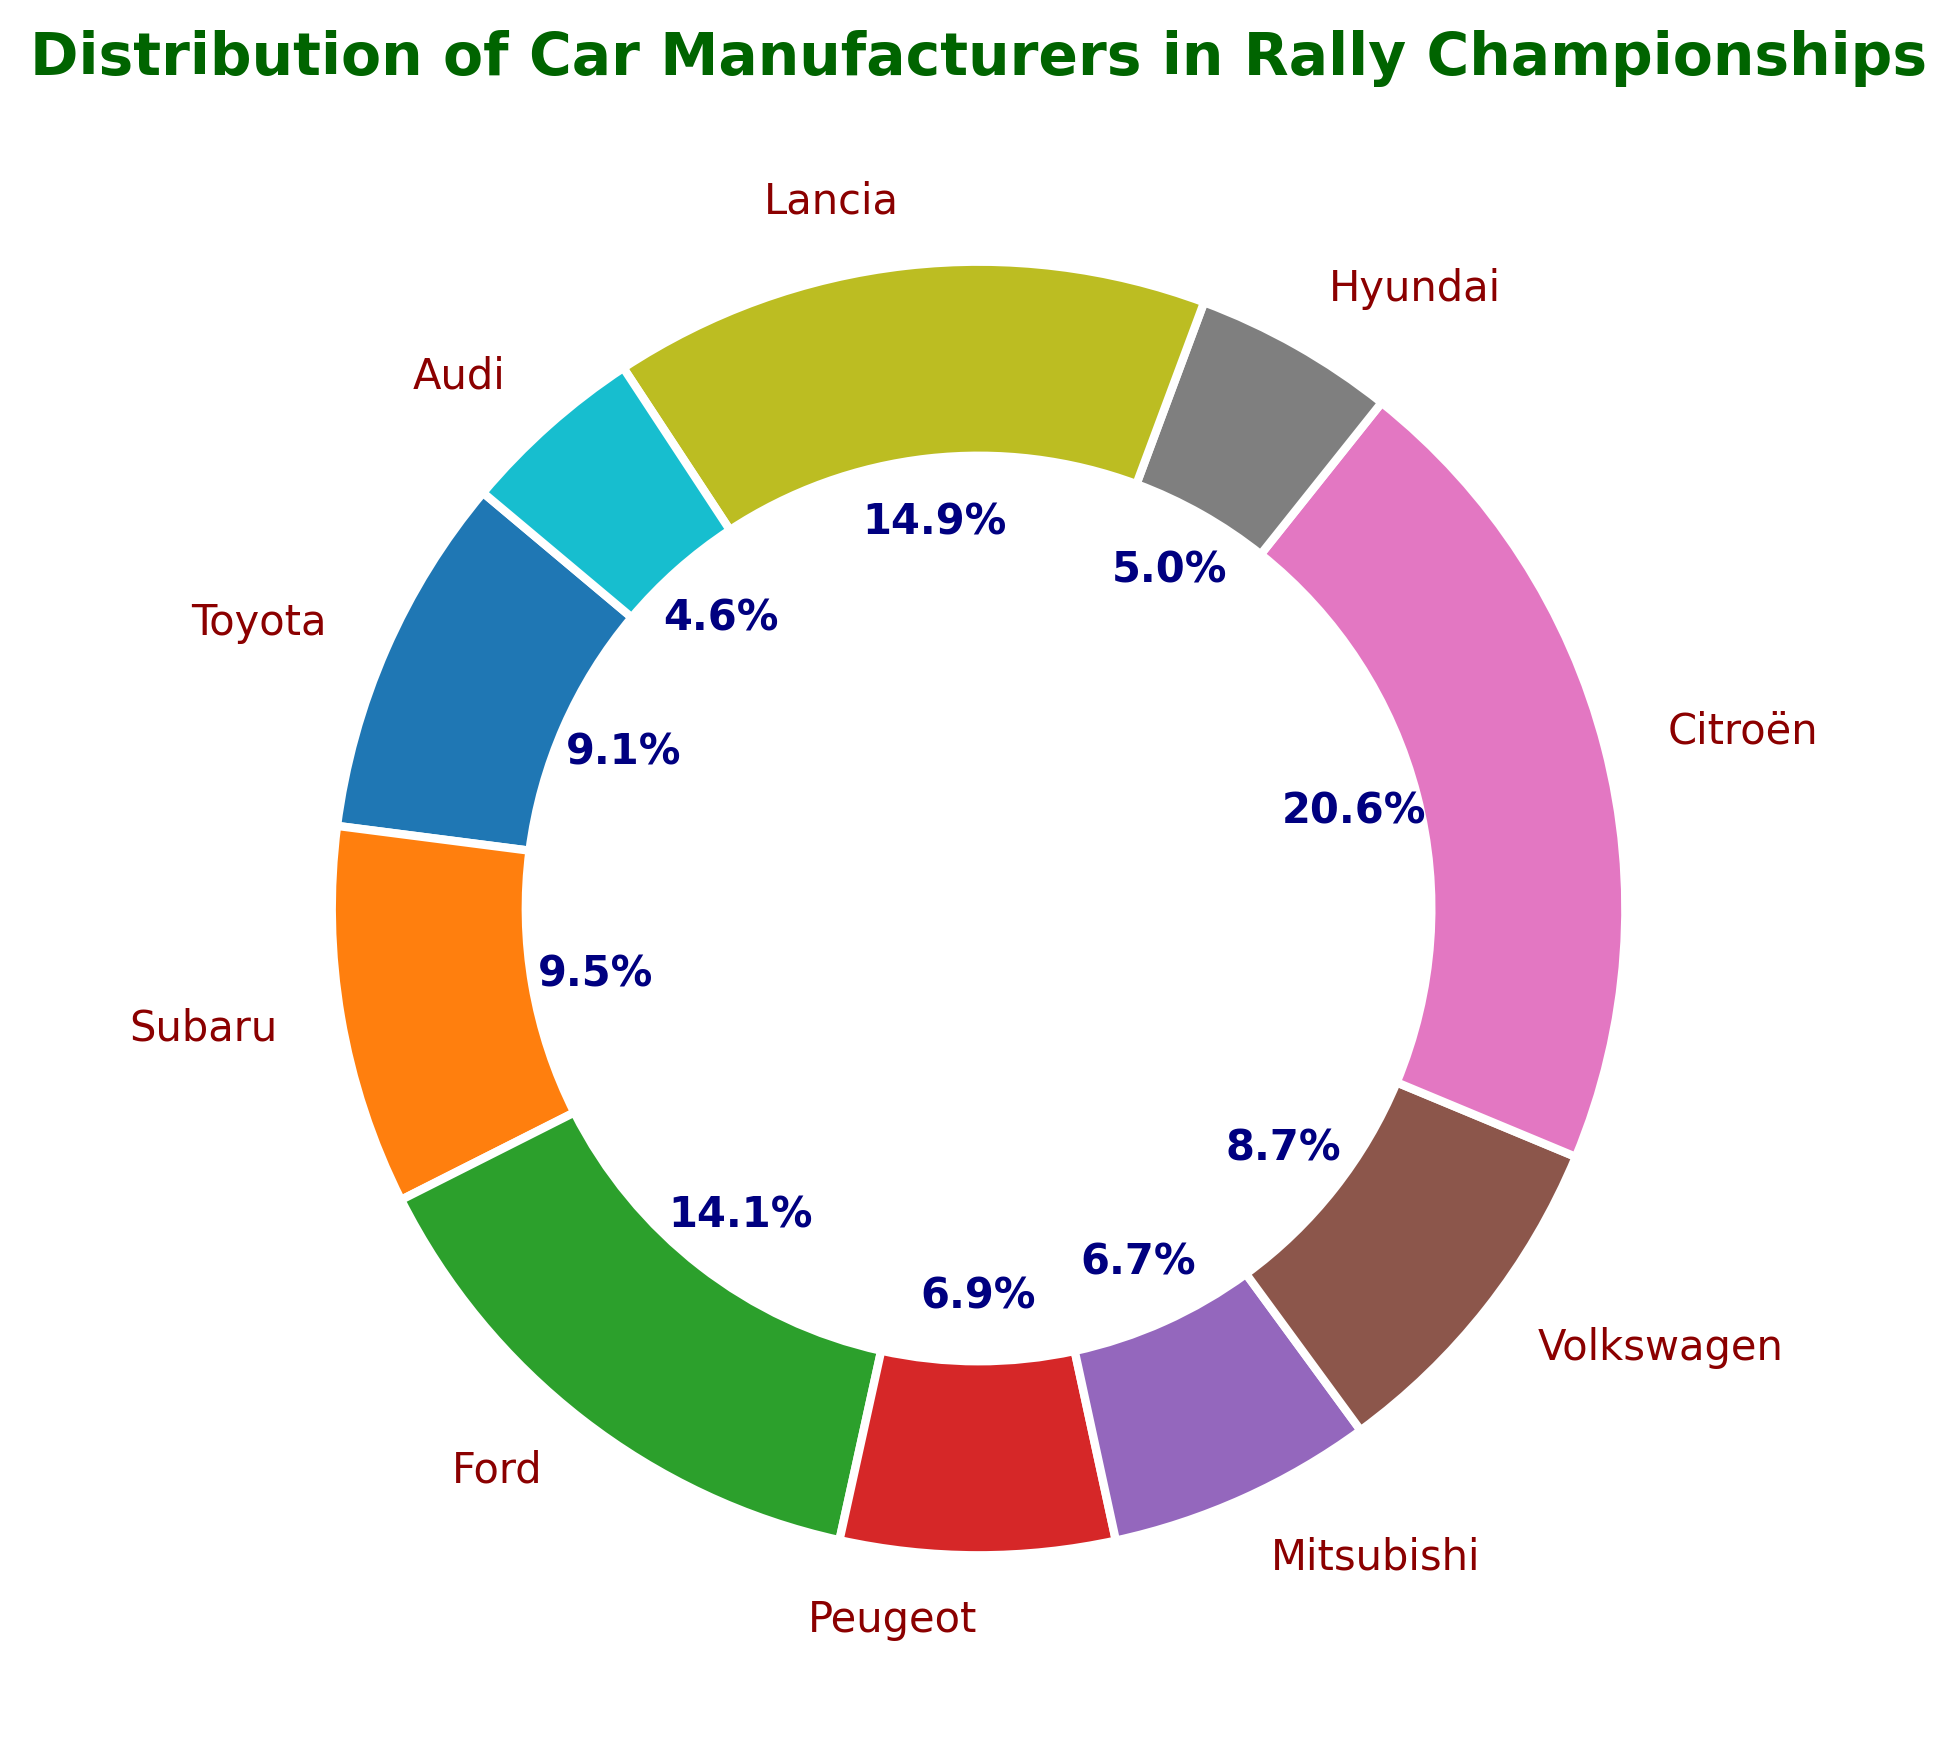What percentage of wins does Citroën have? Look for the segment labeled "Citroën" and check the percentage value inside or next to it.
Answer: 38.3% Which manufacturer has the smallest share of wins? Identify the segment with the smallest percentage value among all the segments.
Answer: Audi How many more wins does Ford have compared to Toyota? Find the number of wins for Ford (70) and Toyota (45) from the figure, then subtract the number of wins of Toyota from Ford (70 - 45).
Answer: 25 Which manufacturer has a larger share of wins, Subaru or Mitsubishi? Compare the percentage values for Subaru and Mitsubishi from the chart. Subaru has 17.6% and Mitsubishi has 12.3%.
Answer: Subaru What's the combined percentage of total wins for Hyundai and Volkswagen? Add the percentage values for Hyundai (9.4%) and Volkswagen (16.2%).
Answer: 25.6% How many manufacturers have a share of wins greater than 10%? Count the number of segments with percentage values greater than 10%. They are Citroën, Lancia, Ford, Subaru, and Toyota.
Answer: 5 Which manufacturer has the highest share in the chart? Look for the segment with the highest percentage value; it's Citroën with 38.3%.
Answer: Citroën If Toyota and Subaru combined their wins, what would their total percentage be? Add the percentage values for Toyota (16.9%) and Subaru (17.6%).
Answer: 34.5% How does the visual representation of Ford's segment compare to Peugeot's? Observe the size differences between Ford's segment and Peugeot's segment; Ford's segment is larger.
Answer: Ford's segment is larger What is the sum of wins by all manufacturers whose share is below 10%? Identify segments with shares below 10%: Hyundai (9.4%) and Audi (8.6%). Then multiply these percentages by the total wins (256), i.e., (0.094 + 0.086) * 256.
Answer: 46 